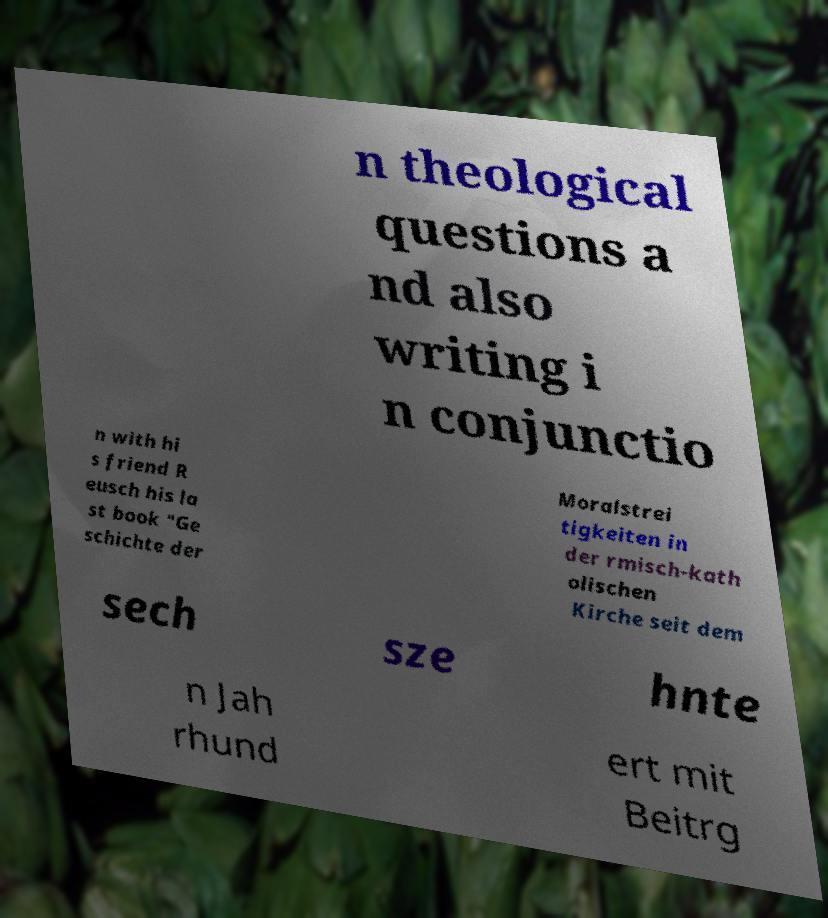Can you accurately transcribe the text from the provided image for me? n theological questions a nd also writing i n conjunctio n with hi s friend R eusch his la st book "Ge schichte der Moralstrei tigkeiten in der rmisch-kath olischen Kirche seit dem sech sze hnte n Jah rhund ert mit Beitrg 